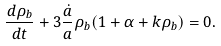<formula> <loc_0><loc_0><loc_500><loc_500>\frac { d \rho _ { b } } { d t } + 3 \frac { \dot { a } } { a } \rho _ { b } ( 1 + \alpha + k \rho _ { b } ) = 0 .</formula> 